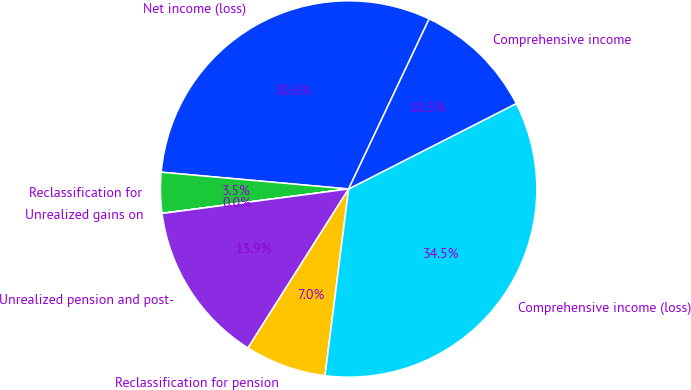Convert chart to OTSL. <chart><loc_0><loc_0><loc_500><loc_500><pie_chart><fcel>Net income (loss)<fcel>Reclassification for<fcel>Unrealized gains on<fcel>Unrealized pension and post-<fcel>Reclassification for pension<fcel>Comprehensive income (loss)<fcel>Comprehensive income<nl><fcel>30.62%<fcel>3.49%<fcel>0.01%<fcel>13.94%<fcel>6.98%<fcel>34.51%<fcel>10.46%<nl></chart> 